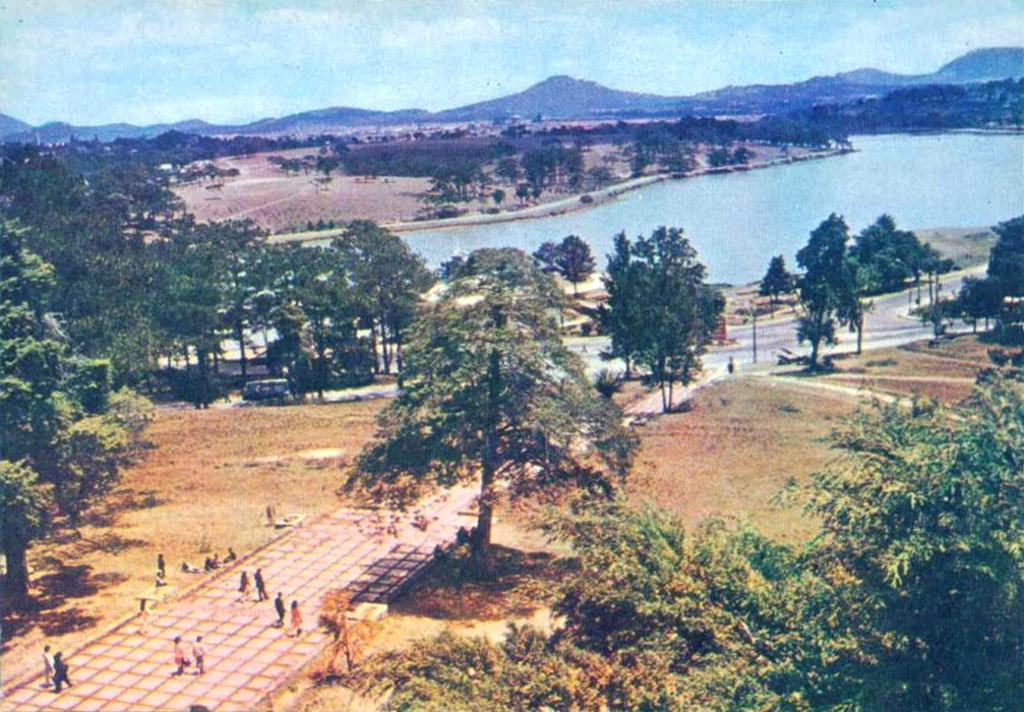What are the people in the image doing? The people in the image are walking on the floor. What can be seen on the road in the image? There is a vehicle on the road in the image. What type of natural environment is visible in the image? There are trees, water, and mountains visible in the image. What part of the natural environment is not visible in the image? The image does not show any deserts or oceans. What is visible in the sky in the image? The sky is visible in the image. What caption would best describe the image? There is no caption provided with the image, so it is not possible to determine the best caption. How many people are starting to walk in the image? The image does not show people starting to walk; it shows people who are already walking. 